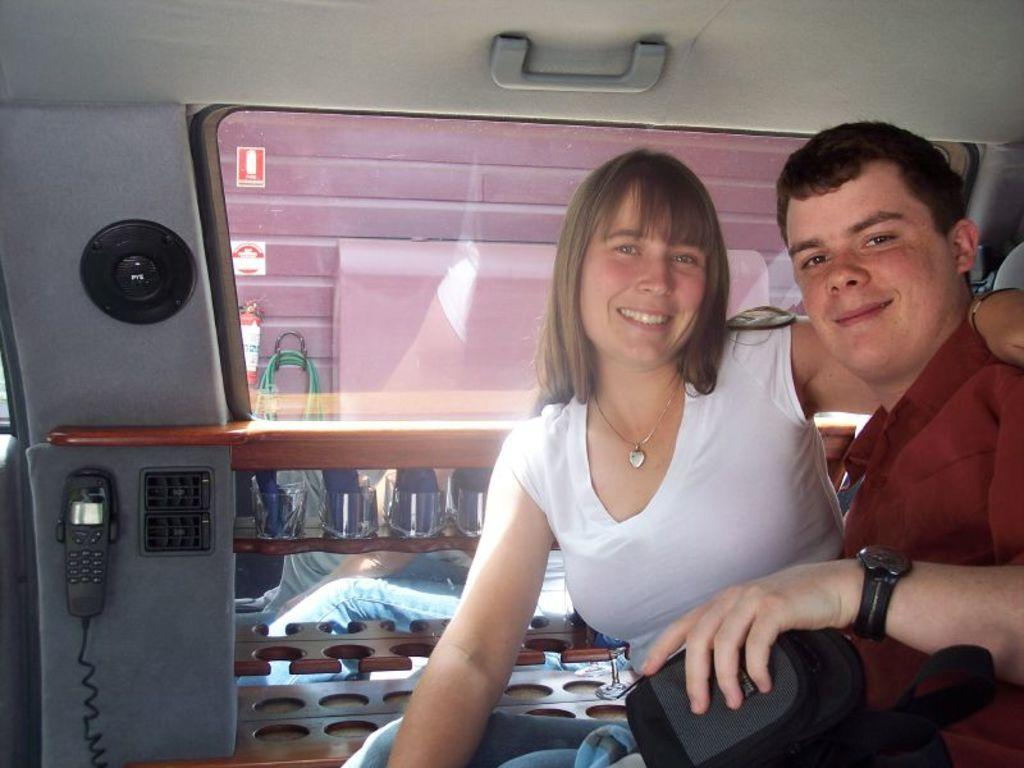How many people are in the image? There are two people in the image. What are the people doing in the image? The people are sitting and smiling. What objects can be seen in the image related to communication? There is a telephone and a speaker in the image. What type of window is present in the image? There is a glass window in the image. What feature can be used to open or close something in the image? There is a handle in the image. What type of potato is being used as a pillow in the image? There is no potato present in the image, let alone being used as a pillow. 